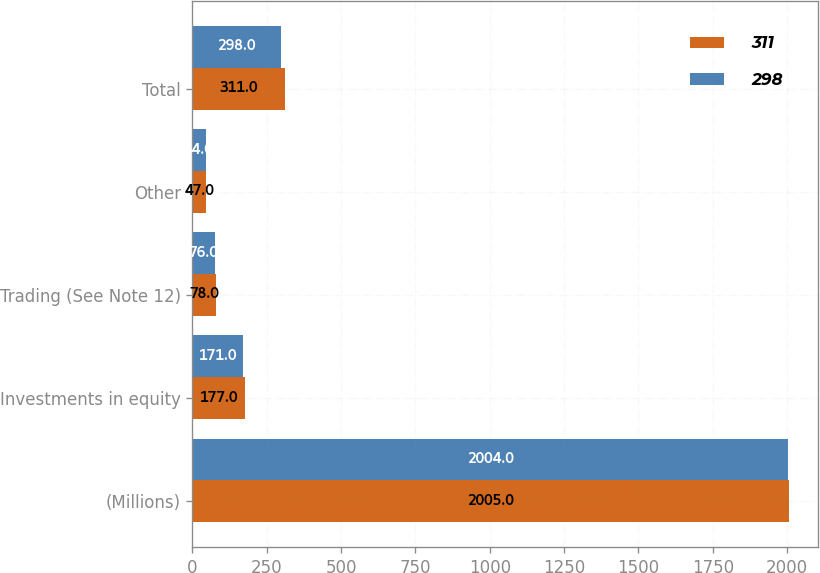Convert chart. <chart><loc_0><loc_0><loc_500><loc_500><stacked_bar_chart><ecel><fcel>(Millions)<fcel>Investments in equity<fcel>Trading (See Note 12)<fcel>Other<fcel>Total<nl><fcel>311<fcel>2005<fcel>177<fcel>78<fcel>47<fcel>311<nl><fcel>298<fcel>2004<fcel>171<fcel>76<fcel>44<fcel>298<nl></chart> 